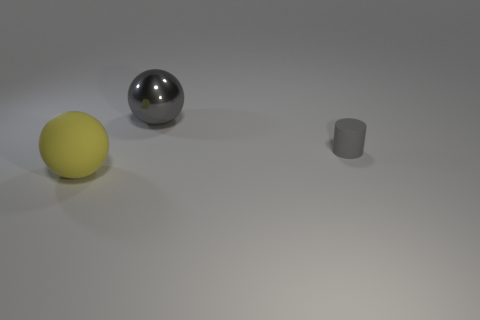Add 2 tiny gray rubber objects. How many objects exist? 5 Subtract all balls. How many objects are left? 1 Subtract all large purple matte balls. Subtract all gray cylinders. How many objects are left? 2 Add 2 metal spheres. How many metal spheres are left? 3 Add 1 gray matte objects. How many gray matte objects exist? 2 Subtract 0 gray cubes. How many objects are left? 3 